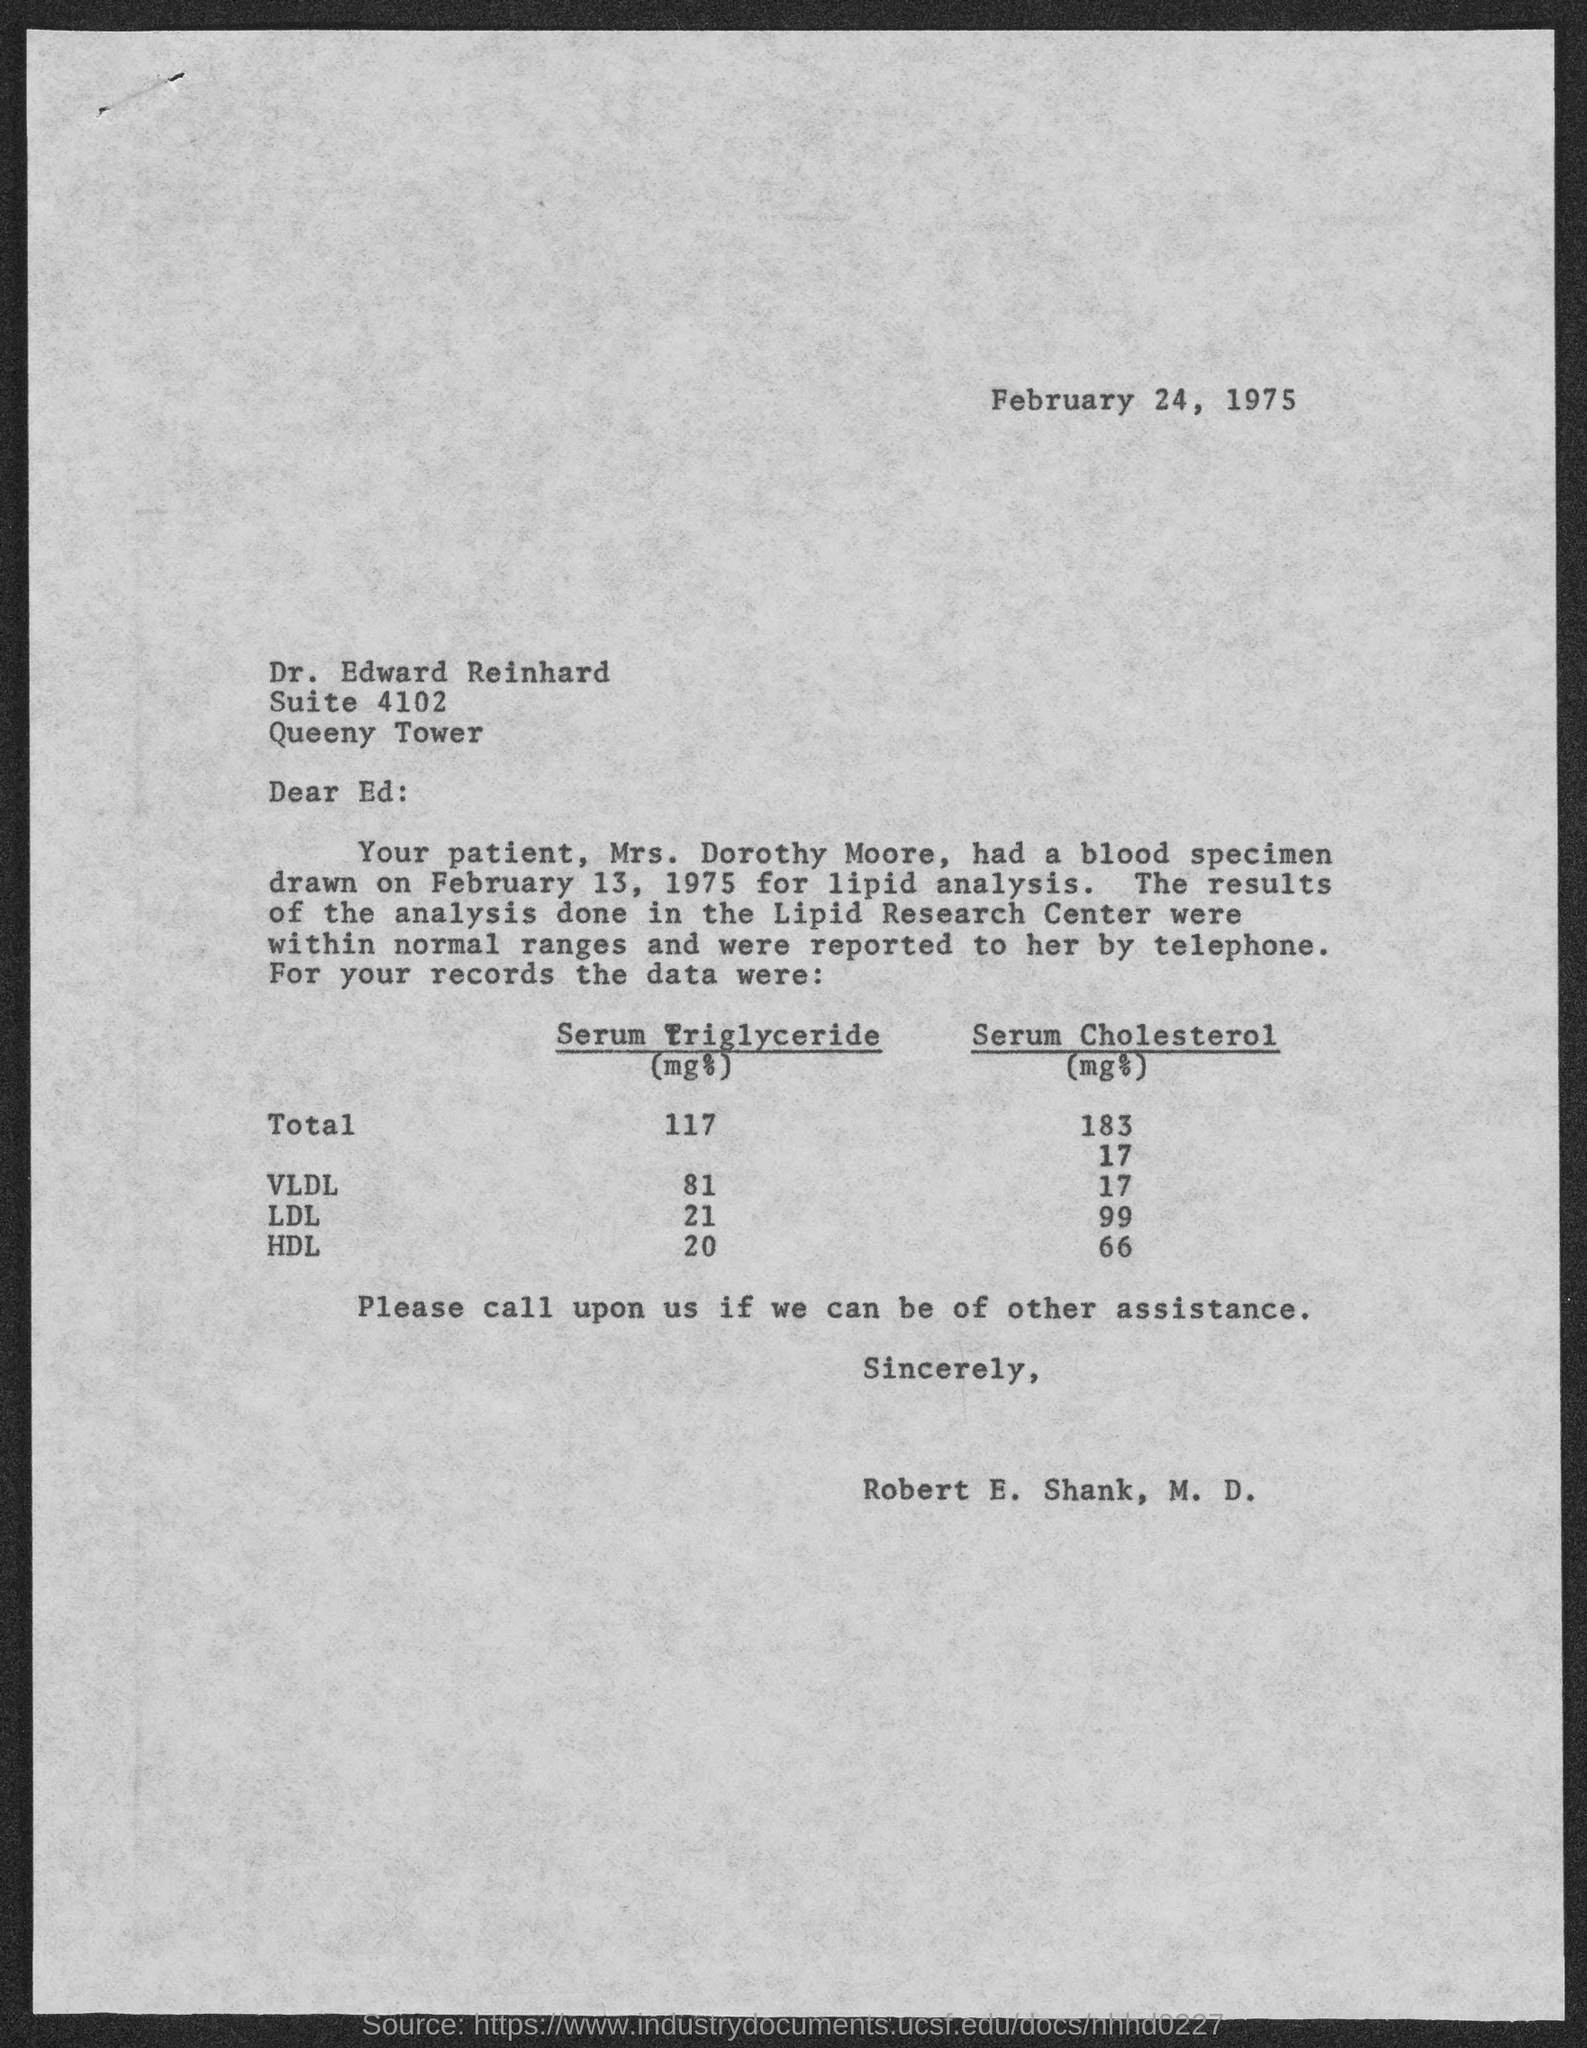Highlight a few significant elements in this photo. The serum cholesterol level of VLDL is 17.... The memorandum is from Robert E. Shank, M.D. The suite number is 4102. The memorandum is addressed to "Ed.. The date mentioned at the top of the document is February 24, 1975. 